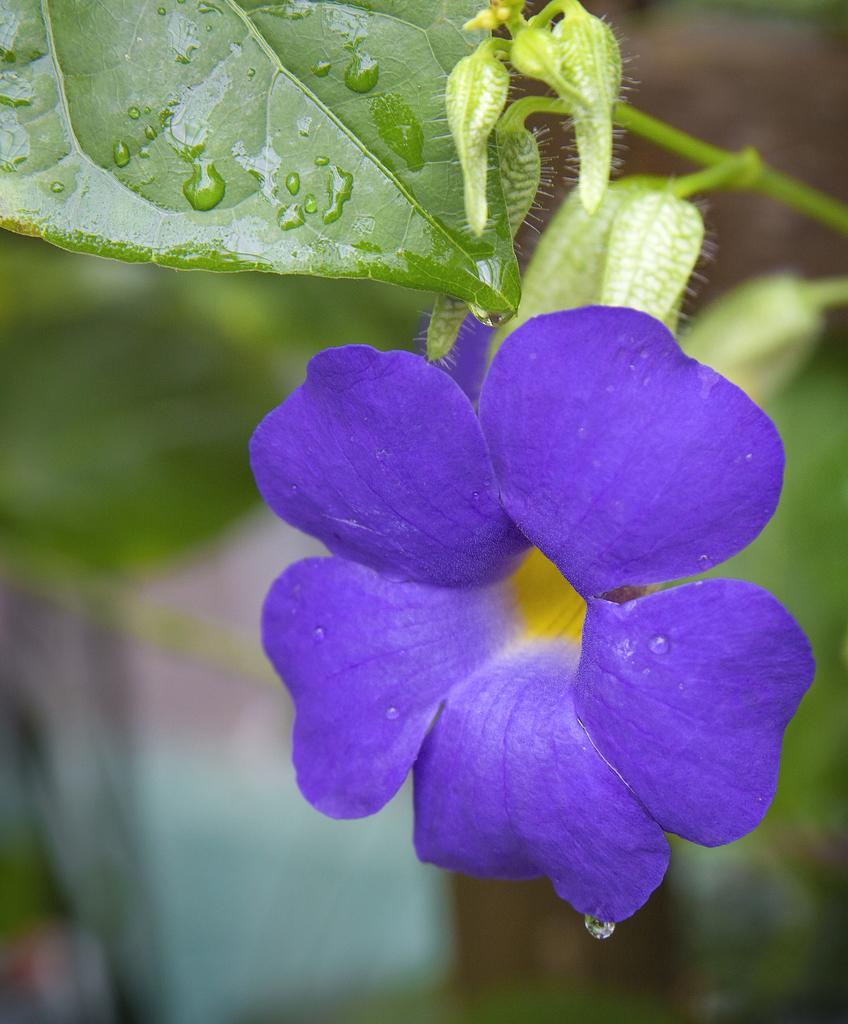What type of plant is visible in the image? There are flowers and buds on the plant in the image. Can you describe the appearance of the plant? The plant has flowers and buds, but the background of the image is blurred. How many cows are visible in the image? There are no cows present in the image; it features a plant with flowers and buds. What type of locket is hanging from the plant in the image? There is no locket present in the image; it features a plant with flowers and buds. 